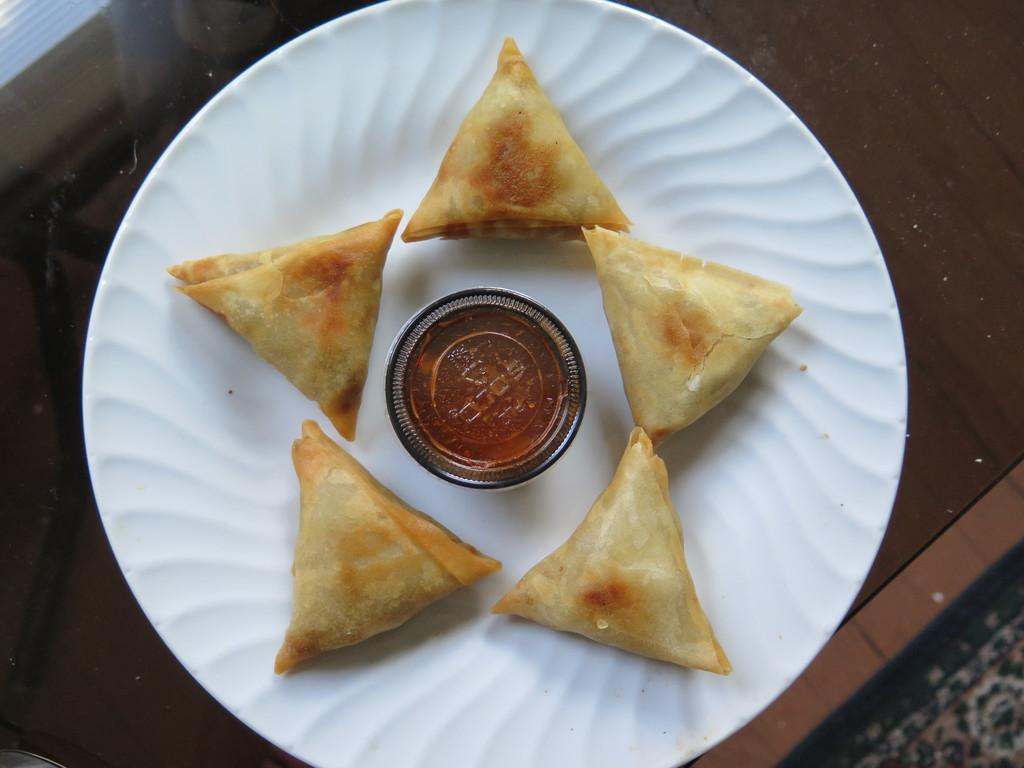What is on the plate that is visible in the image? There is food on a plate in the image. Where is the plate located in the image? The plate is on a table in the image. What can be seen in the bottom right corner of the image? There is a mat in the bottom right corner of the image. What type of alarm is ringing in the image? There is no alarm present in the image. What type of plant can be seen growing on the table in the image? There is no plant visible on the table in the image. 